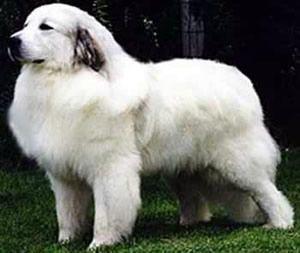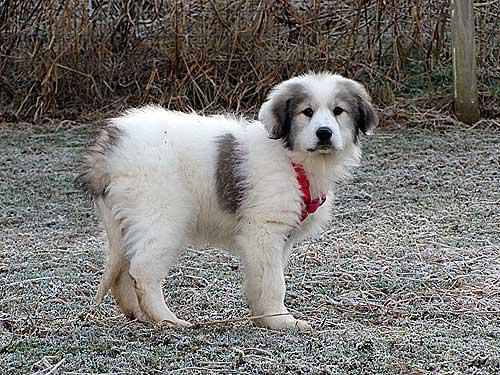The first image is the image on the left, the second image is the image on the right. Given the left and right images, does the statement "An image contains at least two dogs." hold true? Answer yes or no. No. The first image is the image on the left, the second image is the image on the right. For the images shown, is this caption "Two furry white dogs pose standing close together outdoors, in one image." true? Answer yes or no. No. 